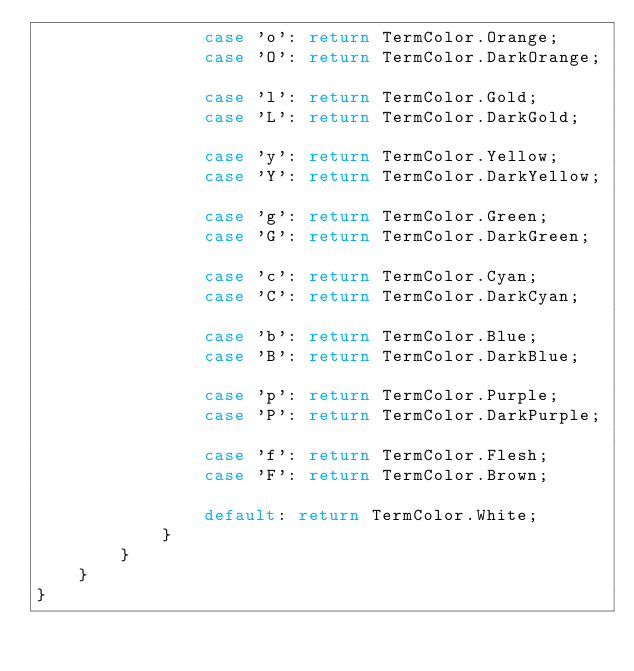Convert code to text. <code><loc_0><loc_0><loc_500><loc_500><_C#_>                case 'o': return TermColor.Orange;
                case 'O': return TermColor.DarkOrange;

                case 'l': return TermColor.Gold;
                case 'L': return TermColor.DarkGold;

                case 'y': return TermColor.Yellow;
                case 'Y': return TermColor.DarkYellow;

                case 'g': return TermColor.Green;
                case 'G': return TermColor.DarkGreen;

                case 'c': return TermColor.Cyan;
                case 'C': return TermColor.DarkCyan;

                case 'b': return TermColor.Blue;
                case 'B': return TermColor.DarkBlue;

                case 'p': return TermColor.Purple;
                case 'P': return TermColor.DarkPurple;

                case 'f': return TermColor.Flesh;
                case 'F': return TermColor.Brown;

                default: return TermColor.White;
            }
        }
    }
}
</code> 